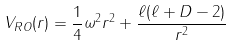<formula> <loc_0><loc_0><loc_500><loc_500>V _ { R O } ( r ) = \frac { 1 } { 4 } \omega ^ { 2 } r ^ { 2 } + \frac { \ell ( \ell + D - 2 ) } { r ^ { 2 } }</formula> 